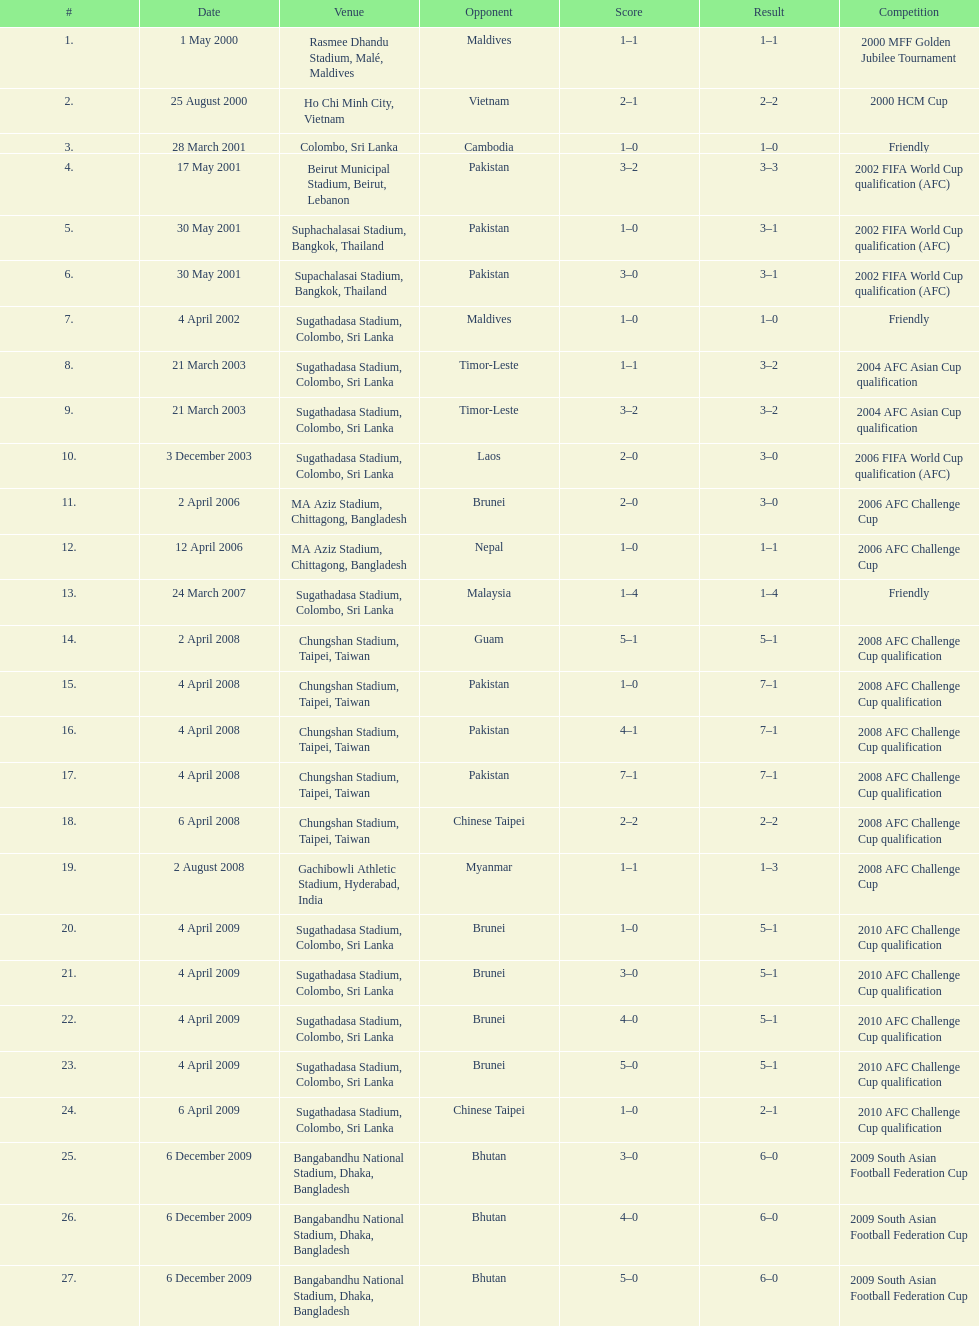What was the total number of goals score in the sri lanka - malaysia game of march 24, 2007? 5. 